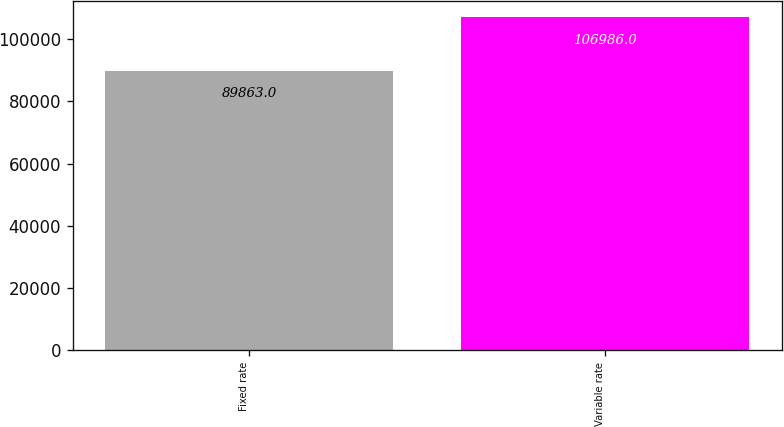Convert chart. <chart><loc_0><loc_0><loc_500><loc_500><bar_chart><fcel>Fixed rate<fcel>Variable rate<nl><fcel>89863<fcel>106986<nl></chart> 